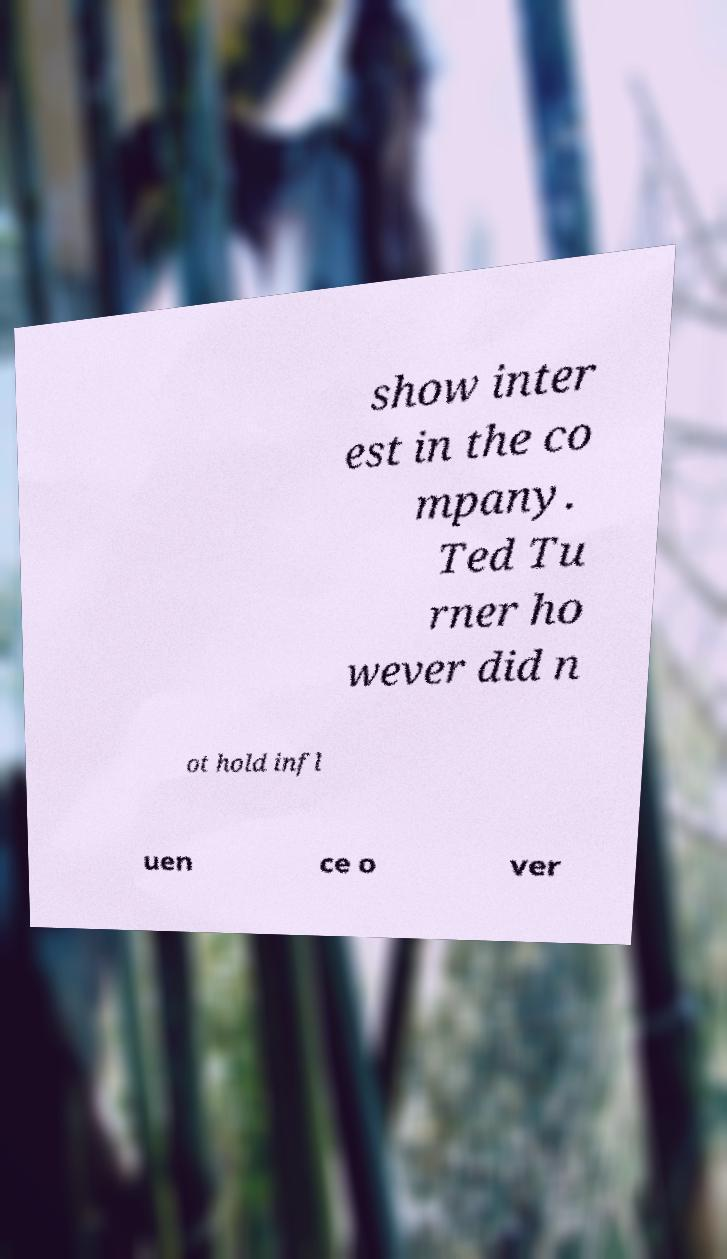For documentation purposes, I need the text within this image transcribed. Could you provide that? show inter est in the co mpany. Ted Tu rner ho wever did n ot hold infl uen ce o ver 